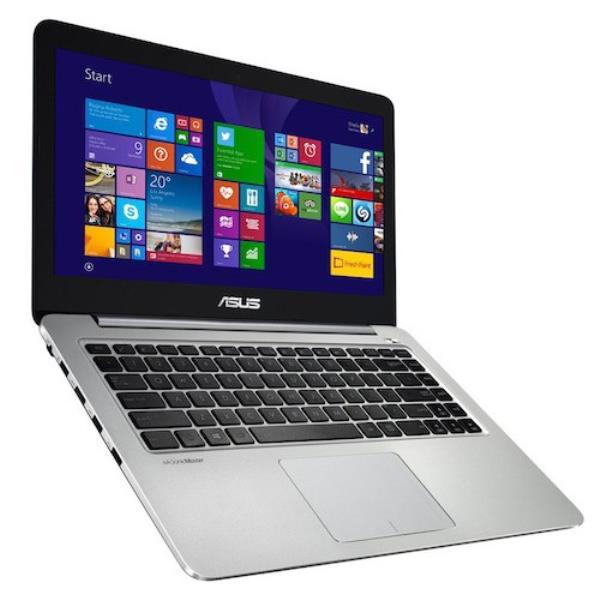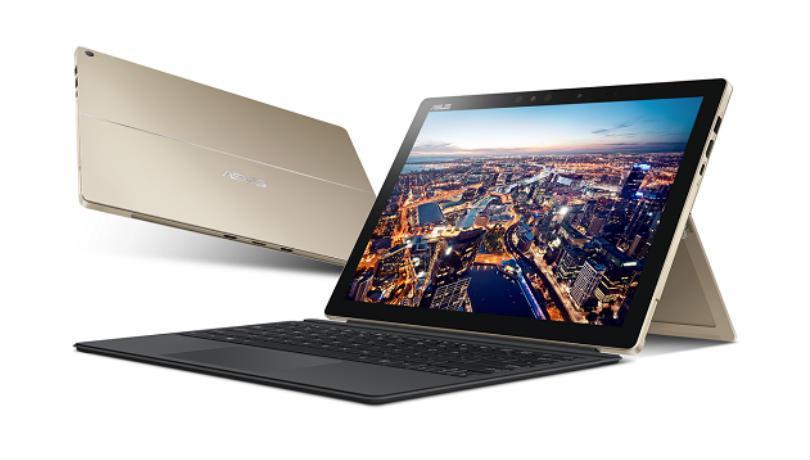The first image is the image on the left, the second image is the image on the right. For the images shown, is this caption "There are three grouped laptops in the image on the right." true? Answer yes or no. No. The first image is the image on the left, the second image is the image on the right. Given the left and right images, does the statement "Three open laptops with imagery on the screens are displayed horizontally in one picture." hold true? Answer yes or no. No. 